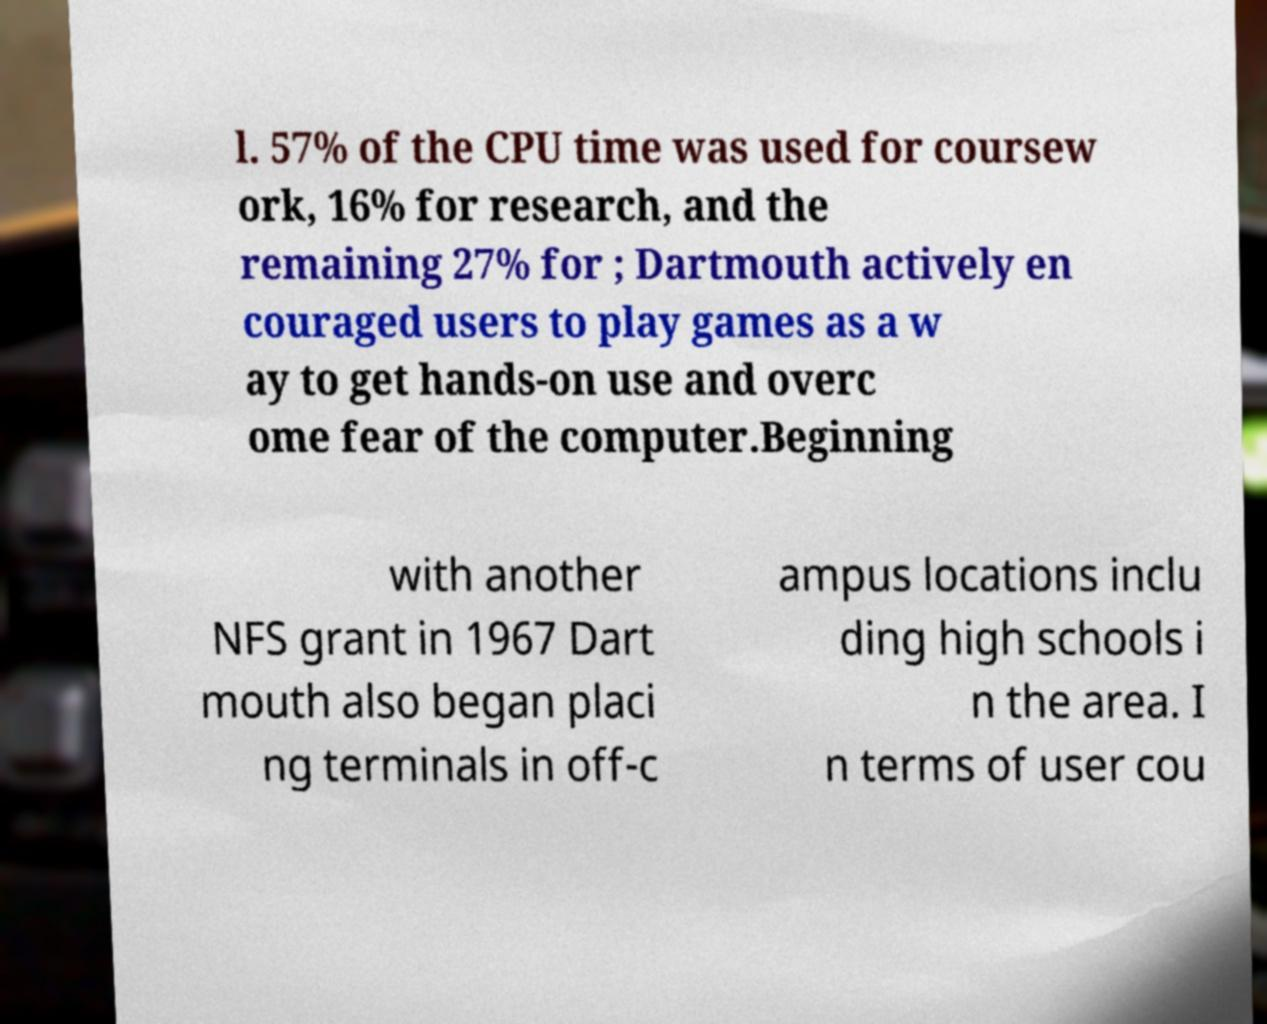Could you assist in decoding the text presented in this image and type it out clearly? l. 57% of the CPU time was used for coursew ork, 16% for research, and the remaining 27% for ; Dartmouth actively en couraged users to play games as a w ay to get hands-on use and overc ome fear of the computer.Beginning with another NFS grant in 1967 Dart mouth also began placi ng terminals in off-c ampus locations inclu ding high schools i n the area. I n terms of user cou 